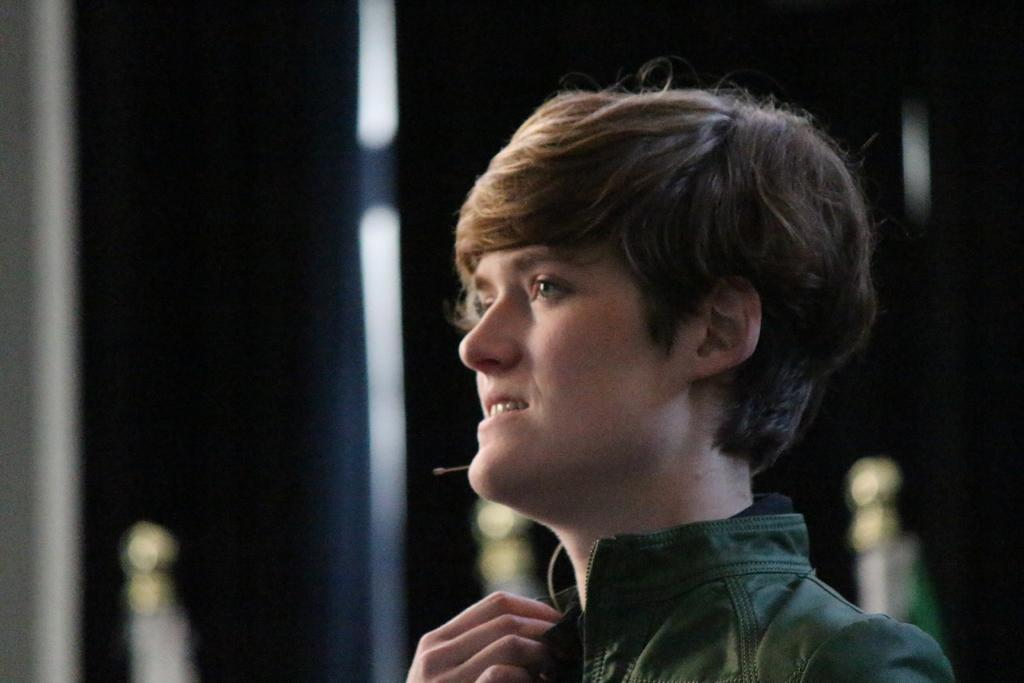What is the main subject of the image? There is a person in the image. What is the person wearing? The person is wearing a jacket. What is the person's facial expression? The person is smiling. Can you describe the background of the image? The background of the image is blurred. What is the tendency of the bricks in the image? There are no bricks present in the image, so it is not possible to determine their tendency. 